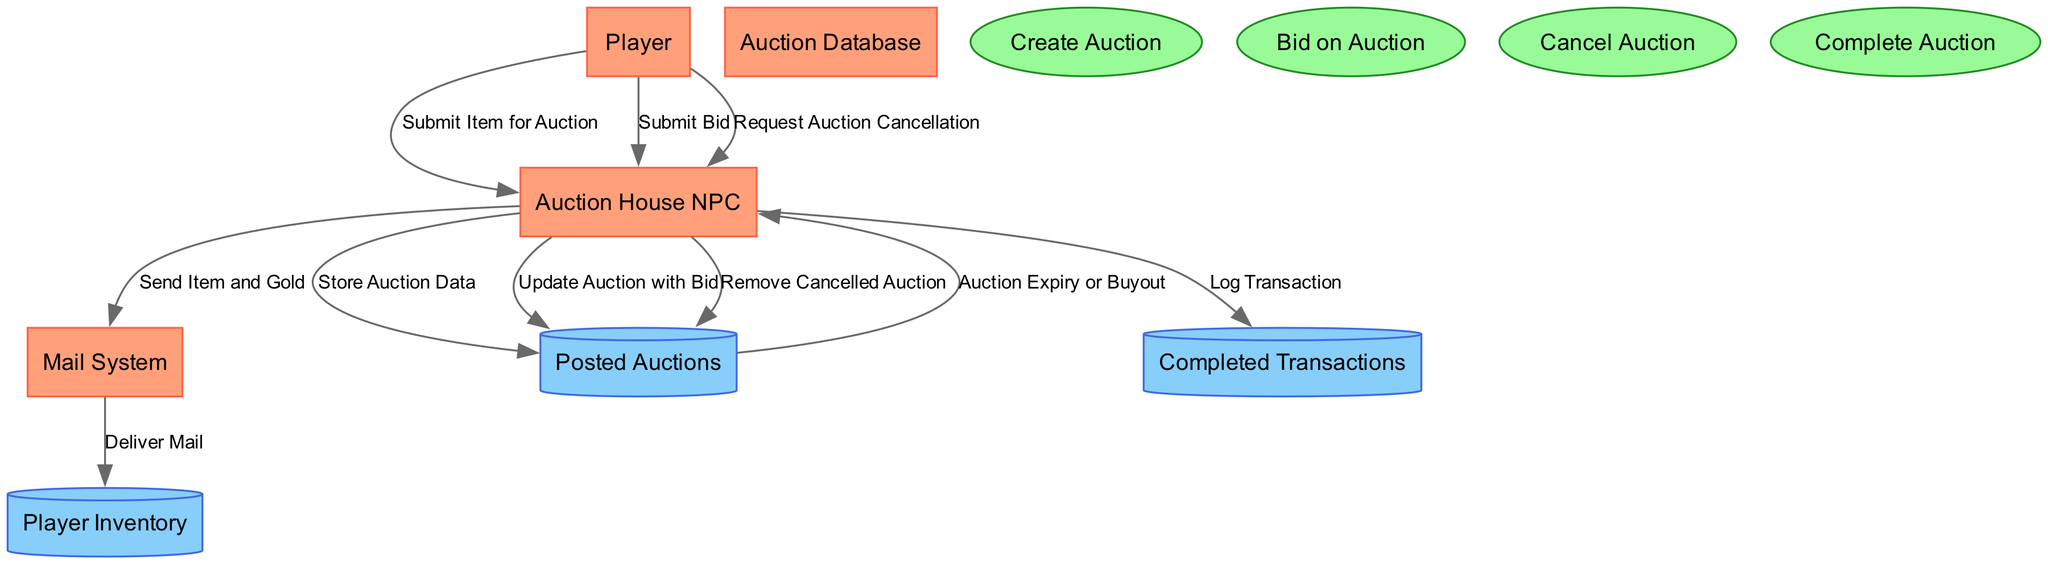What entity initiates the auction house interaction? The diagram shows that the "Player" is the entity responsible for initiating the auction house interaction, as it is the source for various data flows related to auction actions.
Answer: Player How many processes are depicted in the diagram? The diagram lists four processes: "Create Auction," "Bid on Auction," "Cancel Auction," and "Complete Auction." Therefore, the total number of processes is four.
Answer: 4 What does the Auction House NPC do with the auction data after a player submits an item? The "Auction House NPC" processes the auction data by storing it in the "Posted Auctions" database, as indicated by the data flow labeled "Store Auction Data."
Answer: Store Auction Data Which system delivers items and gold to the player's inventory? The diagram specifies that the "Mail System" is responsible for delivering items and gold to the player's inventory, indicated by the data flow labeled "Deliver Mail."
Answer: Mail System In what situation does the Auction House NPC log the completed auction transaction? The Auction House NPC logs the completed auction transaction after the "Auction Expiry or Buyout," which signifies that the auction has ended and is a part of the overall auction process.
Answer: Auction Expiry or Buyout What occurs after a player places a bid on an existing auction? After a player places a bid, the Auction House NPC updates the auction data with the new bid, as described by the data flow labeled "Update Auction with Bid."
Answer: Update Auction with Bid How does a player cancel their active auction? A player cancels their active auction by requesting cancellation from the Auction House NPC, which is represented in the diagram as the data flow labeled "Request Auction Cancellation."
Answer: Request Auction Cancellation What happens to a cancelled auction? Once a player cancels their auction, the Auction House NPC removes the cancelled auction from the active listings, which is depicted in the diagram with the data flow labeled "Remove Cancelled Auction."
Answer: Remove Cancelled Auction What is the data store for all completed auction transactions? According to the diagram, the data store that holds all completed auction transactions is designated as "Completed Transactions."
Answer: Completed Transactions 